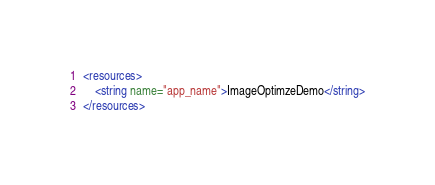Convert code to text. <code><loc_0><loc_0><loc_500><loc_500><_XML_><resources>
    <string name="app_name">ImageOptimzeDemo</string>
</resources>
</code> 